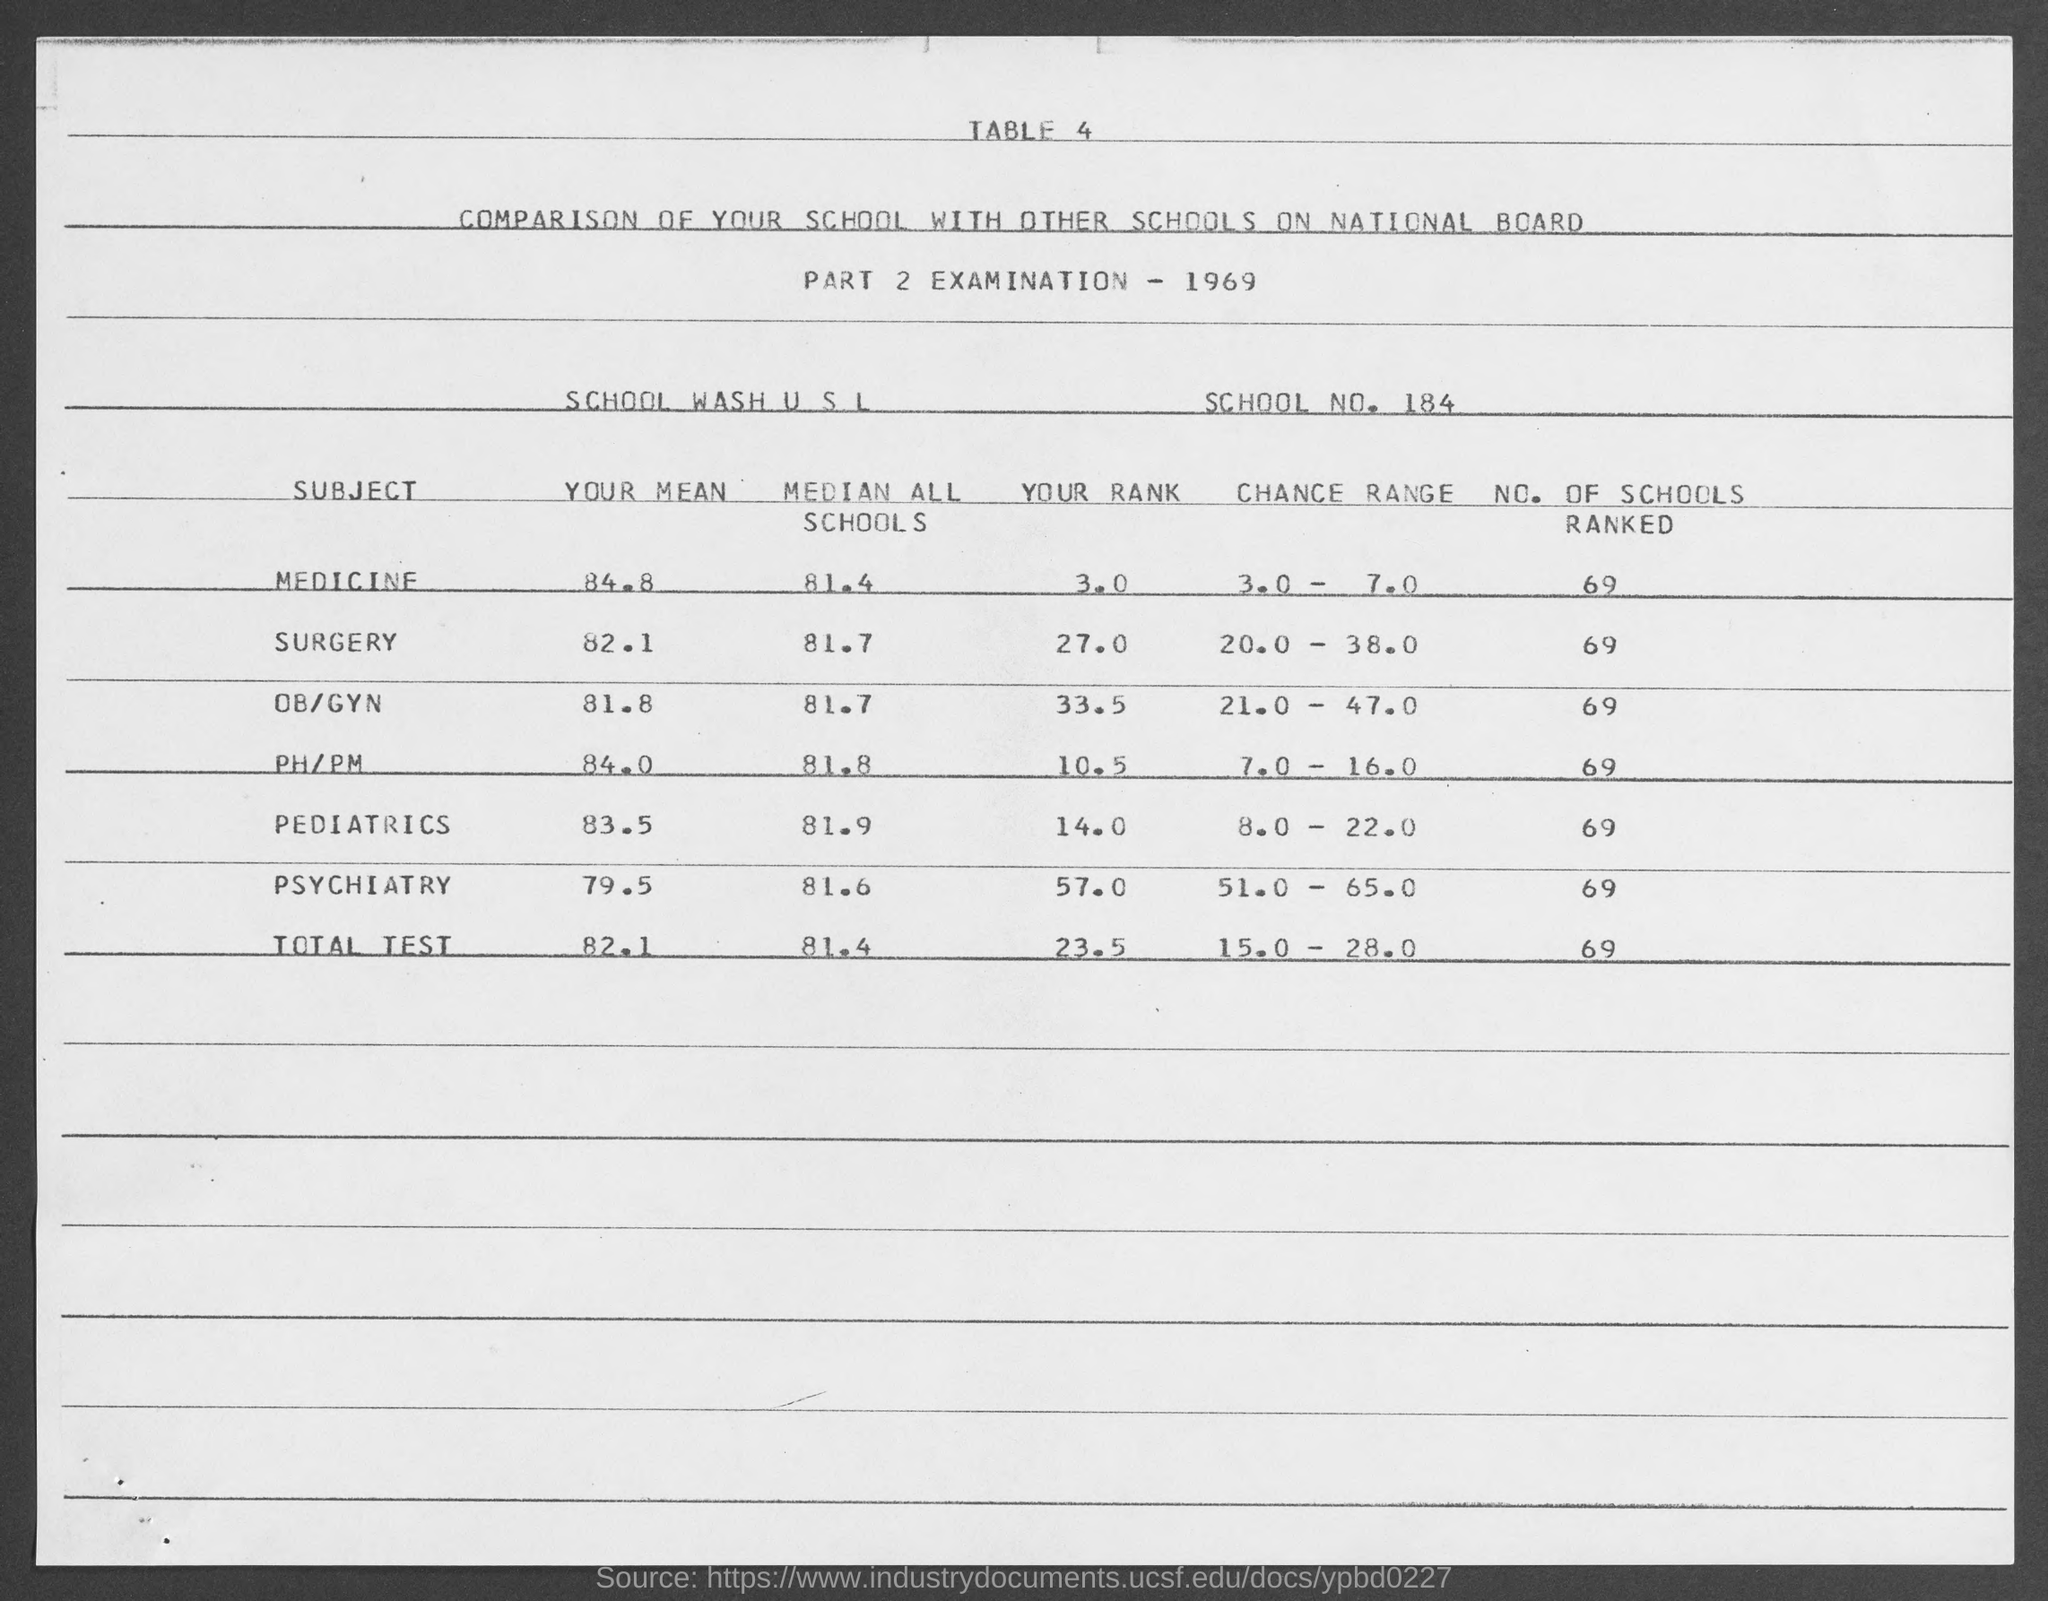Mention a couple of crucial points in this snapshot. There are 69 schools ranked for medicine. There are 69 schools that have been ranked for pediatrics. The range for the total number of tests conducted for all subjects is 15.0 to 28.0. The school number mentioned in the document is 184. The median of all schools in the total test conducted for all subjects is 81.4. 